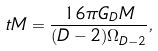Convert formula to latex. <formula><loc_0><loc_0><loc_500><loc_500>\ t M = \frac { 1 6 \pi G _ { D } M } { ( D - 2 ) \Omega _ { D - 2 } } ,</formula> 